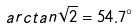Convert formula to latex. <formula><loc_0><loc_0><loc_500><loc_500>a r c t a n \sqrt { 2 } = 5 4 . 7 ^ { \circ }</formula> 